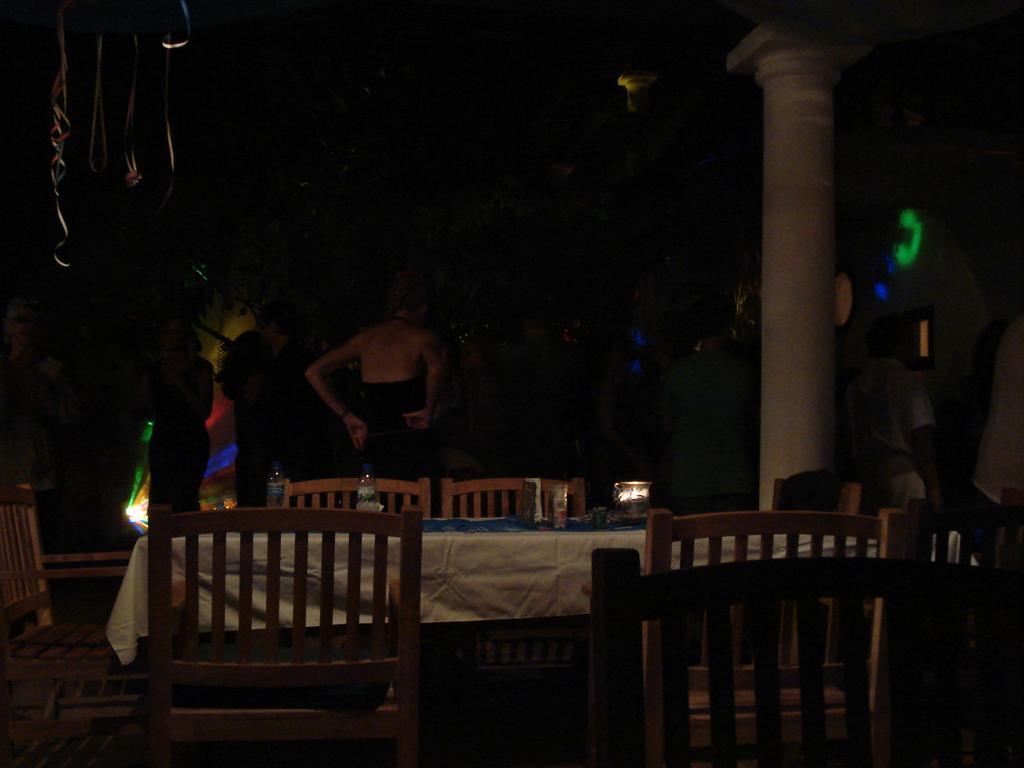Describe this image in one or two sentences. In this image I can see a woman wearing black dress is standing and few other persons standing. I can see a table with white cloth on it and few chairs around it. I can see few lights, few decorative ribbons, a pillar and the dark background. 